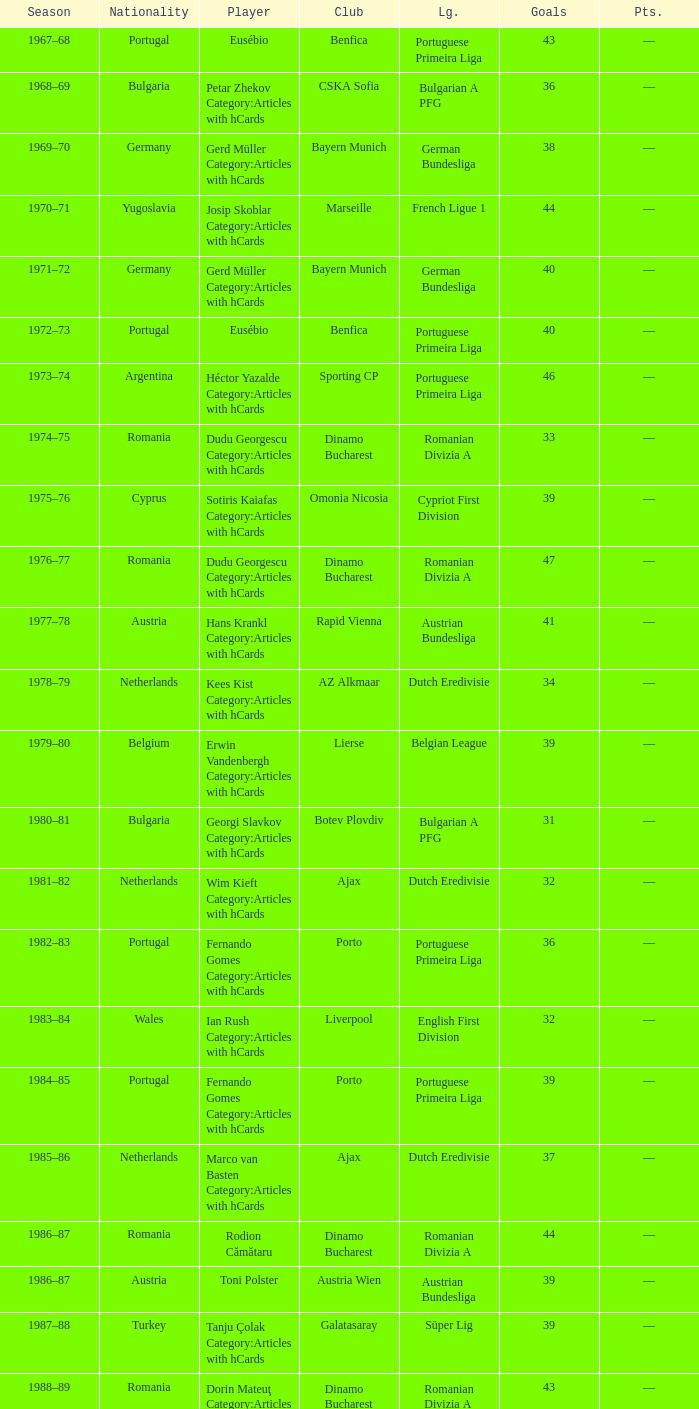Which player was in the Omonia Nicosia club? Sotiris Kaiafas Category:Articles with hCards. 